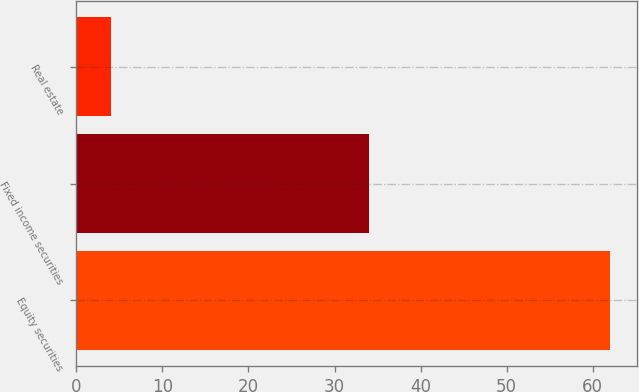<chart> <loc_0><loc_0><loc_500><loc_500><bar_chart><fcel>Equity securities<fcel>Fixed income securities<fcel>Real estate<nl><fcel>62<fcel>34<fcel>4<nl></chart> 